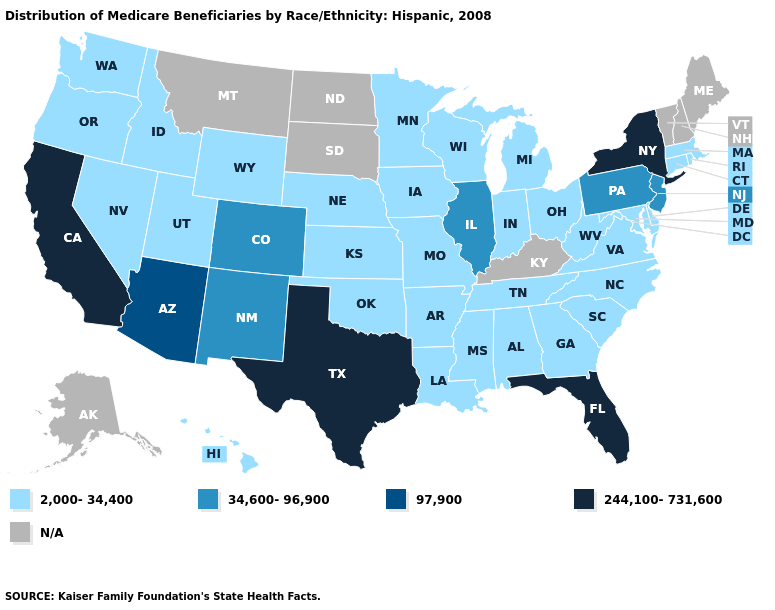What is the value of Kansas?
Answer briefly. 2,000-34,400. What is the value of Wyoming?
Write a very short answer. 2,000-34,400. Name the states that have a value in the range N/A?
Concise answer only. Alaska, Kentucky, Maine, Montana, New Hampshire, North Dakota, South Dakota, Vermont. Which states have the lowest value in the USA?
Be succinct. Alabama, Arkansas, Connecticut, Delaware, Georgia, Hawaii, Idaho, Indiana, Iowa, Kansas, Louisiana, Maryland, Massachusetts, Michigan, Minnesota, Mississippi, Missouri, Nebraska, Nevada, North Carolina, Ohio, Oklahoma, Oregon, Rhode Island, South Carolina, Tennessee, Utah, Virginia, Washington, West Virginia, Wisconsin, Wyoming. Is the legend a continuous bar?
Short answer required. No. What is the value of Mississippi?
Write a very short answer. 2,000-34,400. Among the states that border New Jersey , which have the lowest value?
Give a very brief answer. Delaware. What is the value of New York?
Give a very brief answer. 244,100-731,600. What is the value of Rhode Island?
Be succinct. 2,000-34,400. What is the lowest value in the USA?
Give a very brief answer. 2,000-34,400. What is the value of Alaska?
Be succinct. N/A. Is the legend a continuous bar?
Give a very brief answer. No. Which states hav the highest value in the South?
Concise answer only. Florida, Texas. 